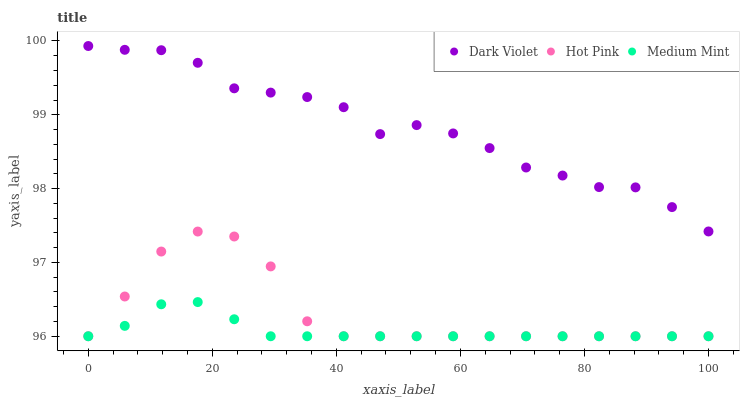Does Medium Mint have the minimum area under the curve?
Answer yes or no. Yes. Does Dark Violet have the maximum area under the curve?
Answer yes or no. Yes. Does Hot Pink have the minimum area under the curve?
Answer yes or no. No. Does Hot Pink have the maximum area under the curve?
Answer yes or no. No. Is Medium Mint the smoothest?
Answer yes or no. Yes. Is Dark Violet the roughest?
Answer yes or no. Yes. Is Hot Pink the smoothest?
Answer yes or no. No. Is Hot Pink the roughest?
Answer yes or no. No. Does Medium Mint have the lowest value?
Answer yes or no. Yes. Does Dark Violet have the lowest value?
Answer yes or no. No. Does Dark Violet have the highest value?
Answer yes or no. Yes. Does Hot Pink have the highest value?
Answer yes or no. No. Is Medium Mint less than Dark Violet?
Answer yes or no. Yes. Is Dark Violet greater than Hot Pink?
Answer yes or no. Yes. Does Medium Mint intersect Hot Pink?
Answer yes or no. Yes. Is Medium Mint less than Hot Pink?
Answer yes or no. No. Is Medium Mint greater than Hot Pink?
Answer yes or no. No. Does Medium Mint intersect Dark Violet?
Answer yes or no. No. 